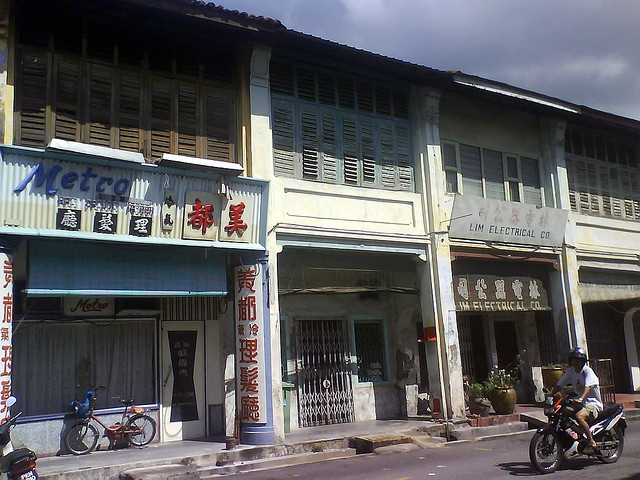Describe the objects in this image and their specific colors. I can see motorcycle in black, gray, maroon, and darkgray tones, people in black, gray, lightgray, and darkgray tones, bicycle in black, darkgray, and gray tones, motorcycle in black, gray, darkgray, and lightgray tones, and potted plant in black, darkgreen, and gray tones in this image. 